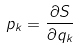Convert formula to latex. <formula><loc_0><loc_0><loc_500><loc_500>p _ { k } = \frac { \partial S } { \partial q _ { k } }</formula> 